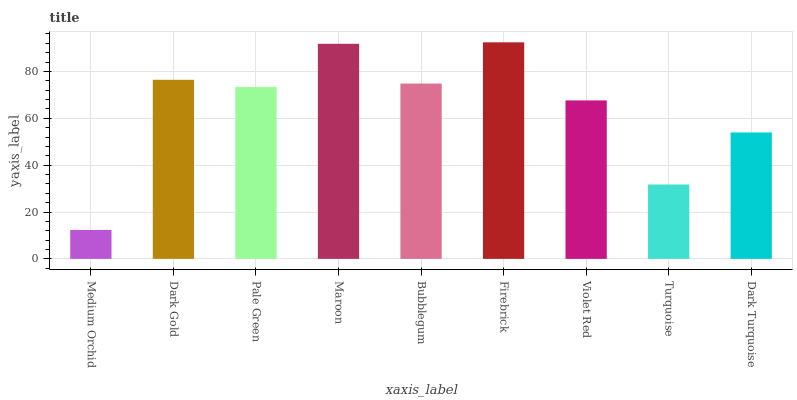Is Dark Gold the minimum?
Answer yes or no. No. Is Dark Gold the maximum?
Answer yes or no. No. Is Dark Gold greater than Medium Orchid?
Answer yes or no. Yes. Is Medium Orchid less than Dark Gold?
Answer yes or no. Yes. Is Medium Orchid greater than Dark Gold?
Answer yes or no. No. Is Dark Gold less than Medium Orchid?
Answer yes or no. No. Is Pale Green the high median?
Answer yes or no. Yes. Is Pale Green the low median?
Answer yes or no. Yes. Is Dark Gold the high median?
Answer yes or no. No. Is Violet Red the low median?
Answer yes or no. No. 